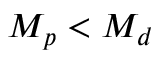Convert formula to latex. <formula><loc_0><loc_0><loc_500><loc_500>M _ { p } < M _ { d }</formula> 